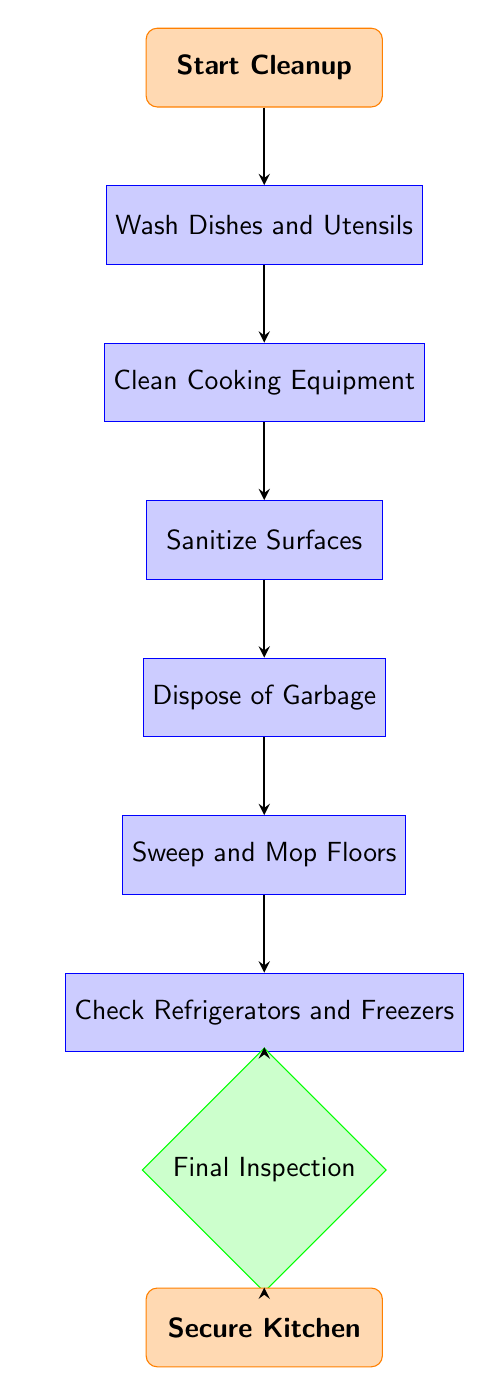What is the starting point of the cleanup process? The flow chart indicates that the process begins with the node labeled "Start Cleanup," which is the first action that needs to be taken.
Answer: Start Cleanup How many total steps are in the cleanup process? By counting the number of nodes in the diagram excluding the start and end nodes, there are seven steps in the cleanup process.
Answer: Seven What is the action taken right after "Wash Dishes and Utensils"? The flow proceeds from the "Wash Dishes and Utensils" node to the next node, which is "Clean Cooking Equipment."
Answer: Clean Cooking Equipment What is the final step in the cleaning process? The flow chart shows that after "Final Inspection," the last action is "Secure Kitchen," indicating that securing the kitchen is the ultimate step.
Answer: Secure Kitchen Which step involves ensuring proper storage of food? The node "Check Refrigerators and Freezers" is specifically designated for checking the storage and organization of food, ensuring it's maintained properly.
Answer: Check Refrigerators and Freezers What action is taken just before sanitizing surfaces? The action that comes immediately before "Sanitize Surfaces" is to "Clean Cooking Equipment," which prepares the surfaces for sanitization.
Answer: Clean Cooking Equipment Which step directly precedes the final inspection? The node "Check Refrigerators and Freezers" comes right before the "Final Inspection," meaning that checking the fridges and freezers is a prerequisite for the final assessment.
Answer: Check Refrigerators and Freezers What tool is suggested for sanitizing surfaces? The description for "Sanitize Surfaces" mentions using "disinfectant spray" as the tool needed for this action.
Answer: Disinfectant spray 